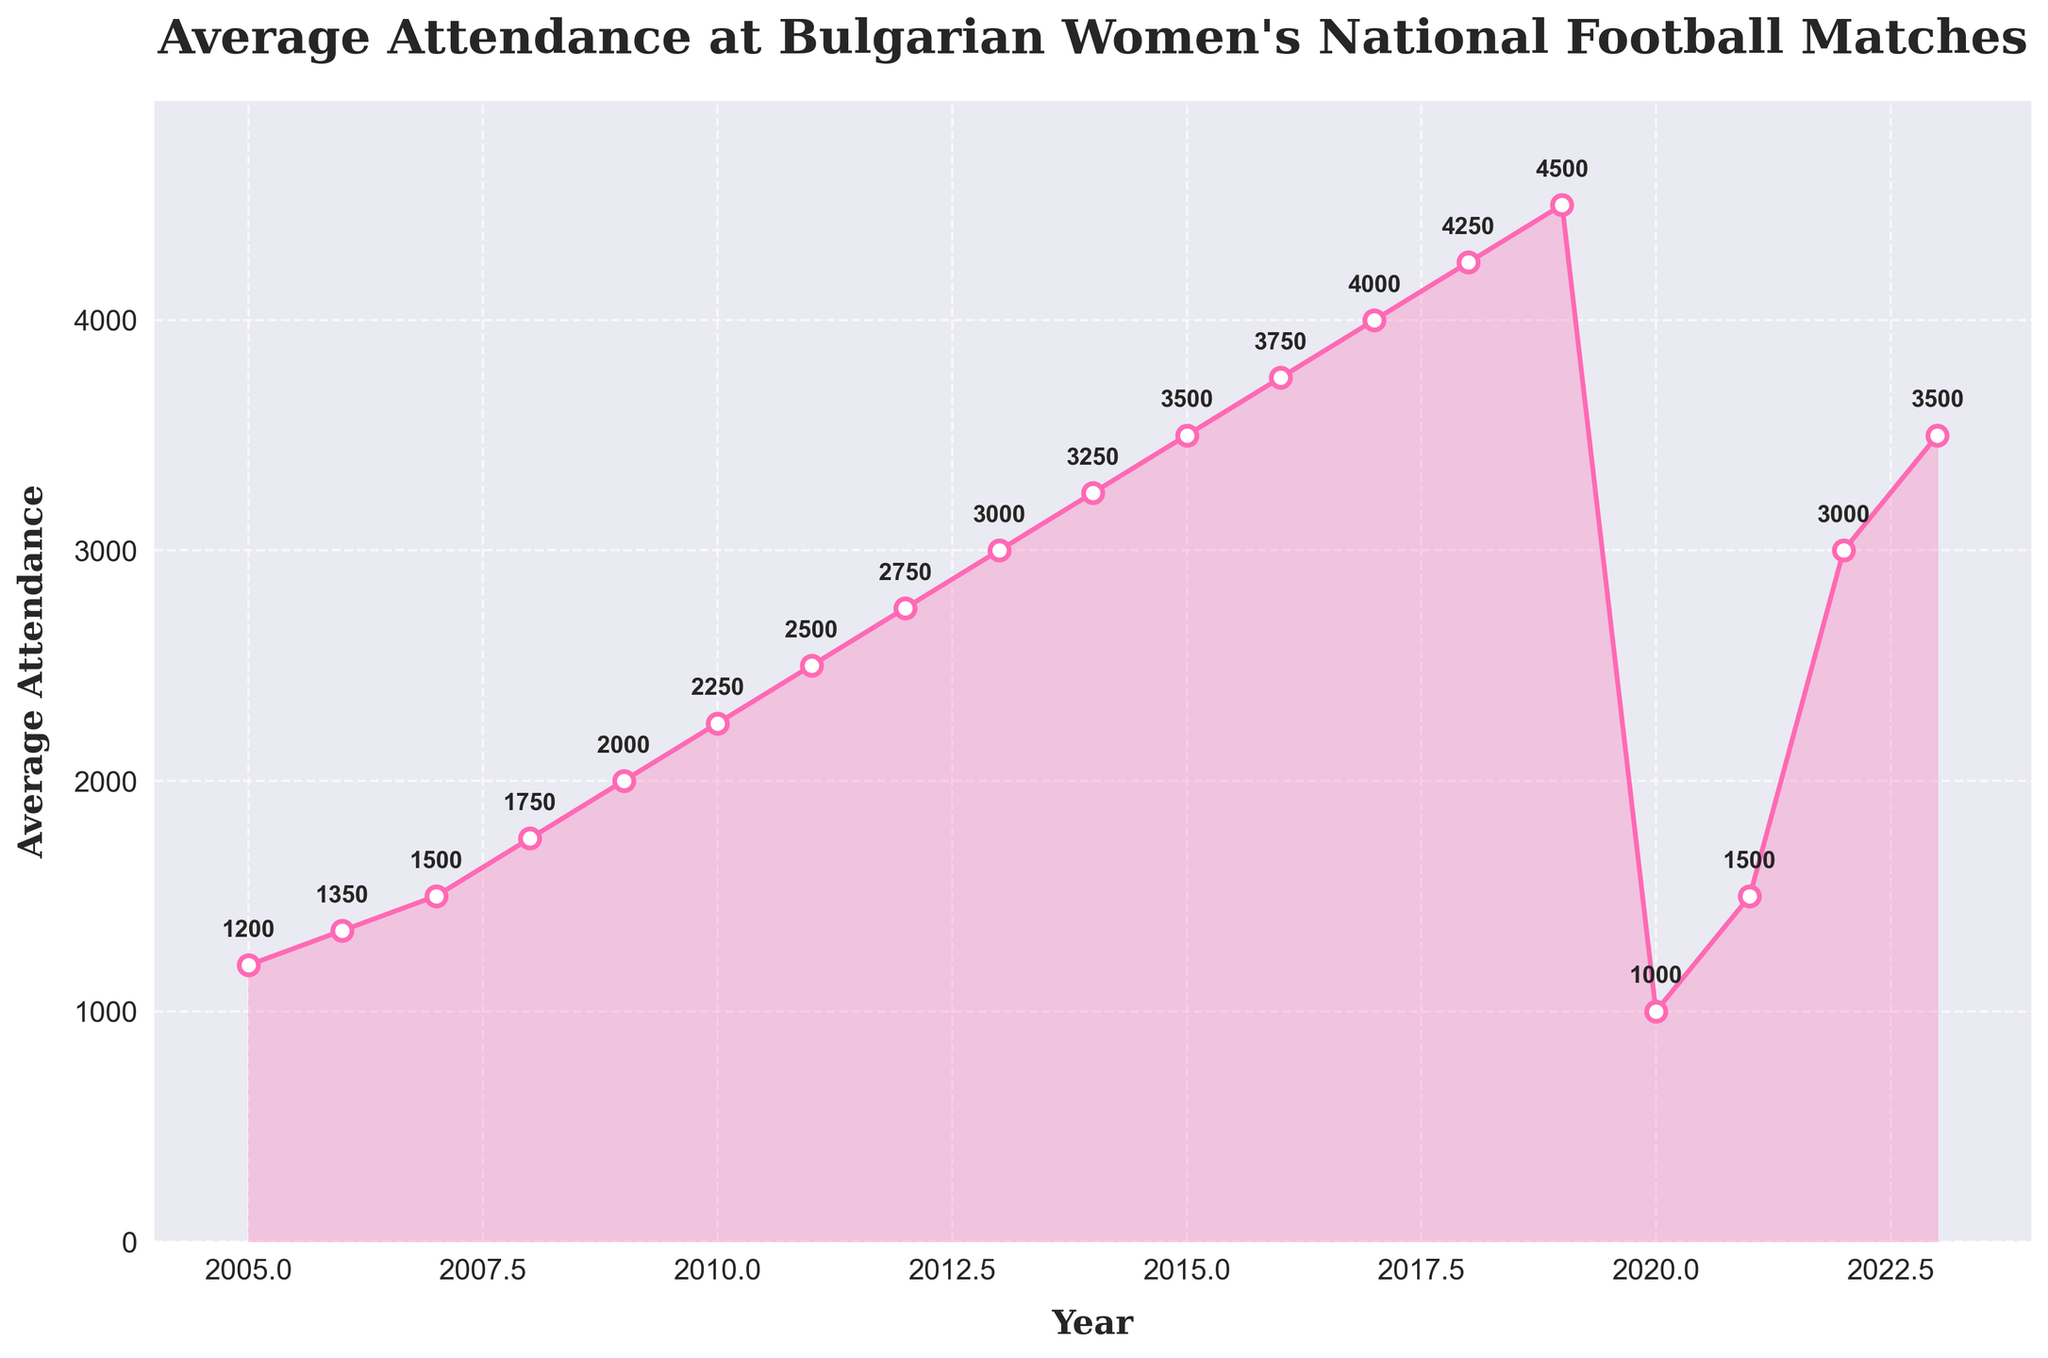How did the average attendance change from 2019 to 2020? The attendance dropped from 4500 in 2019 to 1000 in 2020. The difference is 4500 - 1000 = 3500.
Answer: It decreased by 3500 What was the peak average attendance during the years shown? The highest average attendance was in 2019, with a value of 4500.
Answer: 4500 Which year saw the largest increase in average attendance? The largest increase was from 2021 to 2022, where it went from 1500 to 3000. The increase is 3000 - 1500 = 1500.
Answer: 2021 to 2022 How does the average attendance in 2015 compare to the attendance in 2023? In 2015, the attendance was 3500, and in 2023, it was also 3500. Thus, they are equal.
Answer: They are equal What is the difference in average attendance between 2013 and 2022? The attendance in 2013 was 3000, and in 2022, it was 3000. The difference is 3000 - 3000 = 0.
Answer: 0 What is the average attendance over the first five years? The average attendance from 2005 to 2009 is (1200 + 1350 + 1500 + 1750 + 2000) / 5. This sums to 7800, so the average is 7800 / 5 = 1560.
Answer: 1560 During which years was the attendance lower than 2000? From the data, attendance was lower than 2000 in the years 2005, 2006, 2007, 2008, 2020, and 2021.
Answer: 2005, 2006, 2007, 2008, 2020, and 2021 What is the trend in average attendance from 2005 to 2019? From 2005 to 2019, there is a consistent upward trend with an increase almost every year.
Answer: Increasing trend How many years had an average attendance greater than 3000? The years with attendance greater than 3000 are 2013, 2014, 2015, 2016, 2017, 2018, and 2019, which totals 7 years.
Answer: 7 years 